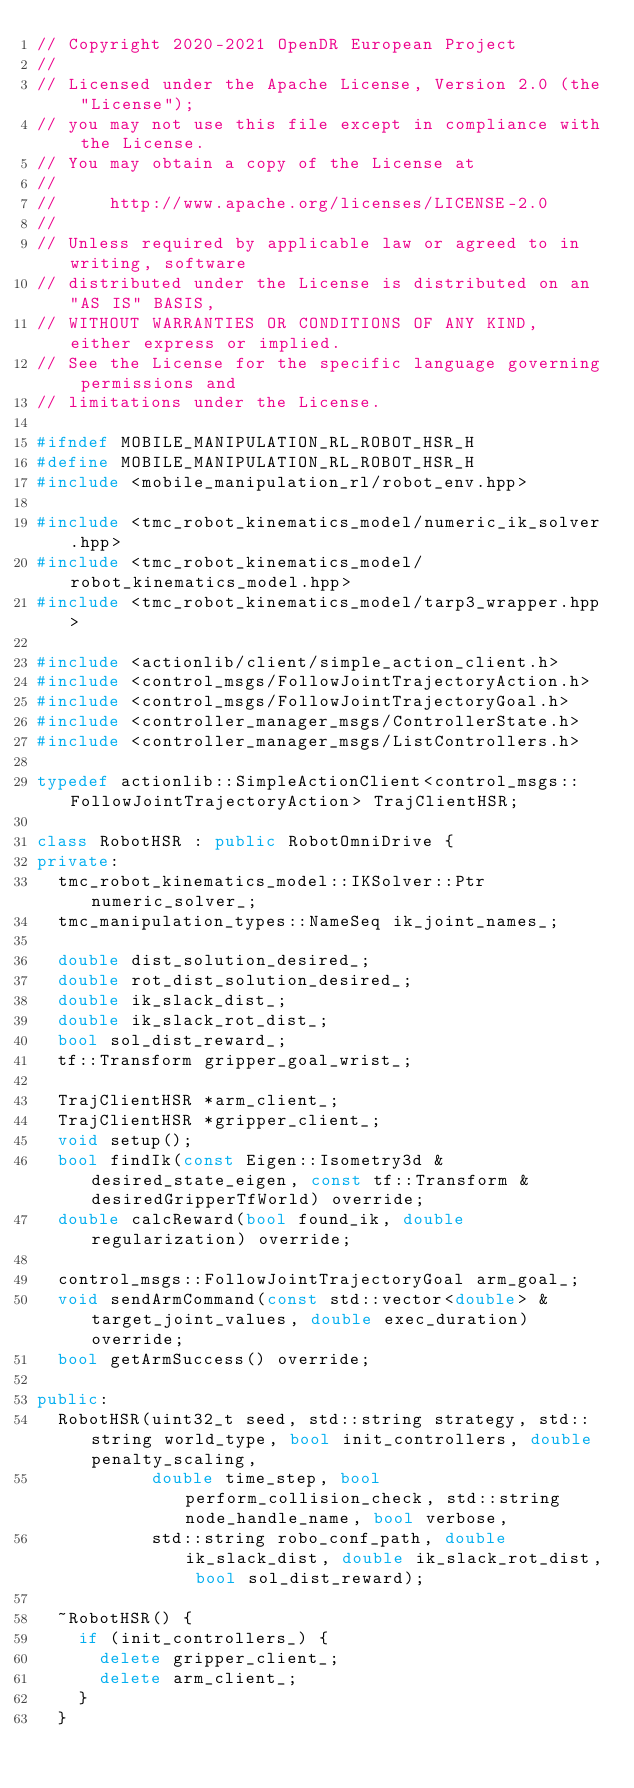Convert code to text. <code><loc_0><loc_0><loc_500><loc_500><_C++_>// Copyright 2020-2021 OpenDR European Project
//
// Licensed under the Apache License, Version 2.0 (the "License");
// you may not use this file except in compliance with the License.
// You may obtain a copy of the License at
//
//     http://www.apache.org/licenses/LICENSE-2.0
//
// Unless required by applicable law or agreed to in writing, software
// distributed under the License is distributed on an "AS IS" BASIS,
// WITHOUT WARRANTIES OR CONDITIONS OF ANY KIND, either express or implied.
// See the License for the specific language governing permissions and
// limitations under the License.

#ifndef MOBILE_MANIPULATION_RL_ROBOT_HSR_H
#define MOBILE_MANIPULATION_RL_ROBOT_HSR_H
#include <mobile_manipulation_rl/robot_env.hpp>

#include <tmc_robot_kinematics_model/numeric_ik_solver.hpp>
#include <tmc_robot_kinematics_model/robot_kinematics_model.hpp>
#include <tmc_robot_kinematics_model/tarp3_wrapper.hpp>

#include <actionlib/client/simple_action_client.h>
#include <control_msgs/FollowJointTrajectoryAction.h>
#include <control_msgs/FollowJointTrajectoryGoal.h>
#include <controller_manager_msgs/ControllerState.h>
#include <controller_manager_msgs/ListControllers.h>

typedef actionlib::SimpleActionClient<control_msgs::FollowJointTrajectoryAction> TrajClientHSR;

class RobotHSR : public RobotOmniDrive {
private:
  tmc_robot_kinematics_model::IKSolver::Ptr numeric_solver_;
  tmc_manipulation_types::NameSeq ik_joint_names_;

  double dist_solution_desired_;
  double rot_dist_solution_desired_;
  double ik_slack_dist_;
  double ik_slack_rot_dist_;
  bool sol_dist_reward_;
  tf::Transform gripper_goal_wrist_;

  TrajClientHSR *arm_client_;
  TrajClientHSR *gripper_client_;
  void setup();
  bool findIk(const Eigen::Isometry3d &desired_state_eigen, const tf::Transform &desiredGripperTfWorld) override;
  double calcReward(bool found_ik, double regularization) override;

  control_msgs::FollowJointTrajectoryGoal arm_goal_;
  void sendArmCommand(const std::vector<double> &target_joint_values, double exec_duration) override;
  bool getArmSuccess() override;

public:
  RobotHSR(uint32_t seed, std::string strategy, std::string world_type, bool init_controllers, double penalty_scaling,
           double time_step, bool perform_collision_check, std::string node_handle_name, bool verbose,
           std::string robo_conf_path, double ik_slack_dist, double ik_slack_rot_dist, bool sol_dist_reward);

  ~RobotHSR() {
    if (init_controllers_) {
      delete gripper_client_;
      delete arm_client_;
    }
  }
</code> 